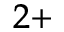Convert formula to latex. <formula><loc_0><loc_0><loc_500><loc_500>^ { 2 + }</formula> 